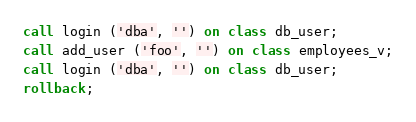<code> <loc_0><loc_0><loc_500><loc_500><_SQL_>call login ('dba', '') on class db_user;
call add_user ('foo', '') on class employees_v;
call login ('dba', '') on class db_user;
rollback;
</code> 